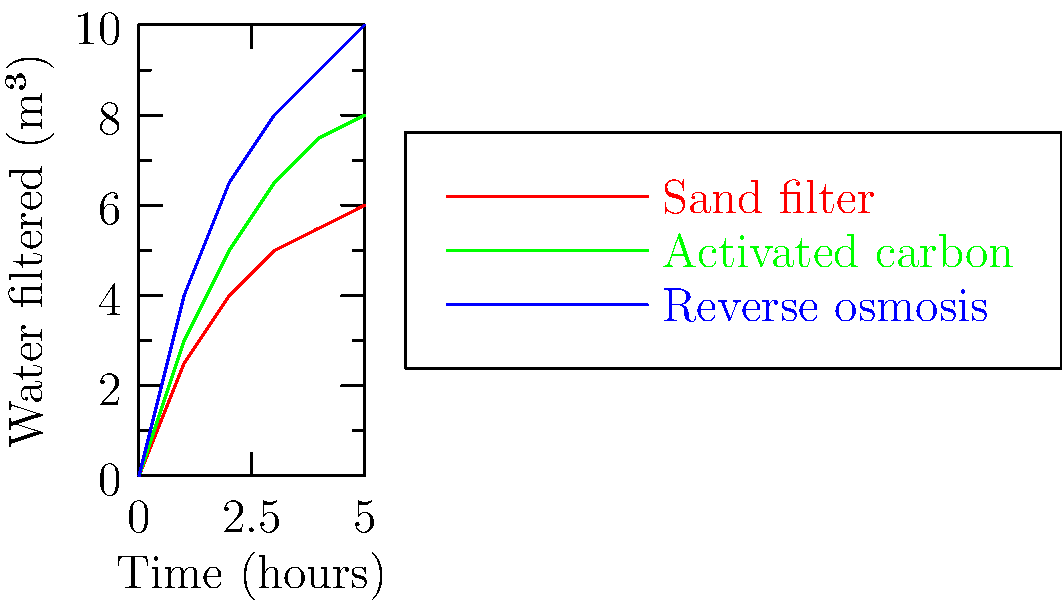Based on the flow rate diagrams of three water filtration systems, which system would be most effective for removing potentially carcinogenic contaminants from a large volume of water over an extended period? Consider both the filtration rate and the known effectiveness of each method in removing harmful substances. To answer this question, we need to analyze the graph and consider the properties of each filtration system:

1. Sand filter (red line):
   - Lowest filtration rate
   - Basic mechanical filtration, removes larger particles
   - Limited effectiveness in removing chemical contaminants or carcinogens

2. Activated carbon filter (green line):
   - Moderate filtration rate
   - Effective at removing organic compounds, chlorine, and some heavy metals
   - Can remove many potential carcinogens, but not all

3. Reverse osmosis (blue line):
   - Highest filtration rate
   - Most effective at removing a wide range of contaminants, including dissolved solids, heavy metals, and organic compounds
   - Capable of removing many potential carcinogens, including those that might pass through other filters

Considering the persona of a health enthusiast concerned about cancer prevention:

1. Effectiveness: Reverse osmosis is the most effective at removing potential carcinogens.
2. Volume: The graph shows that reverse osmosis filters the largest volume of water over time.
3. Long-term use: The higher flow rate of reverse osmosis makes it suitable for extended periods of use.

While activated carbon is also effective for many contaminants, reverse osmosis provides a more comprehensive filtration, which is crucial for removing a wider range of potential carcinogens.
Answer: Reverse osmosis 